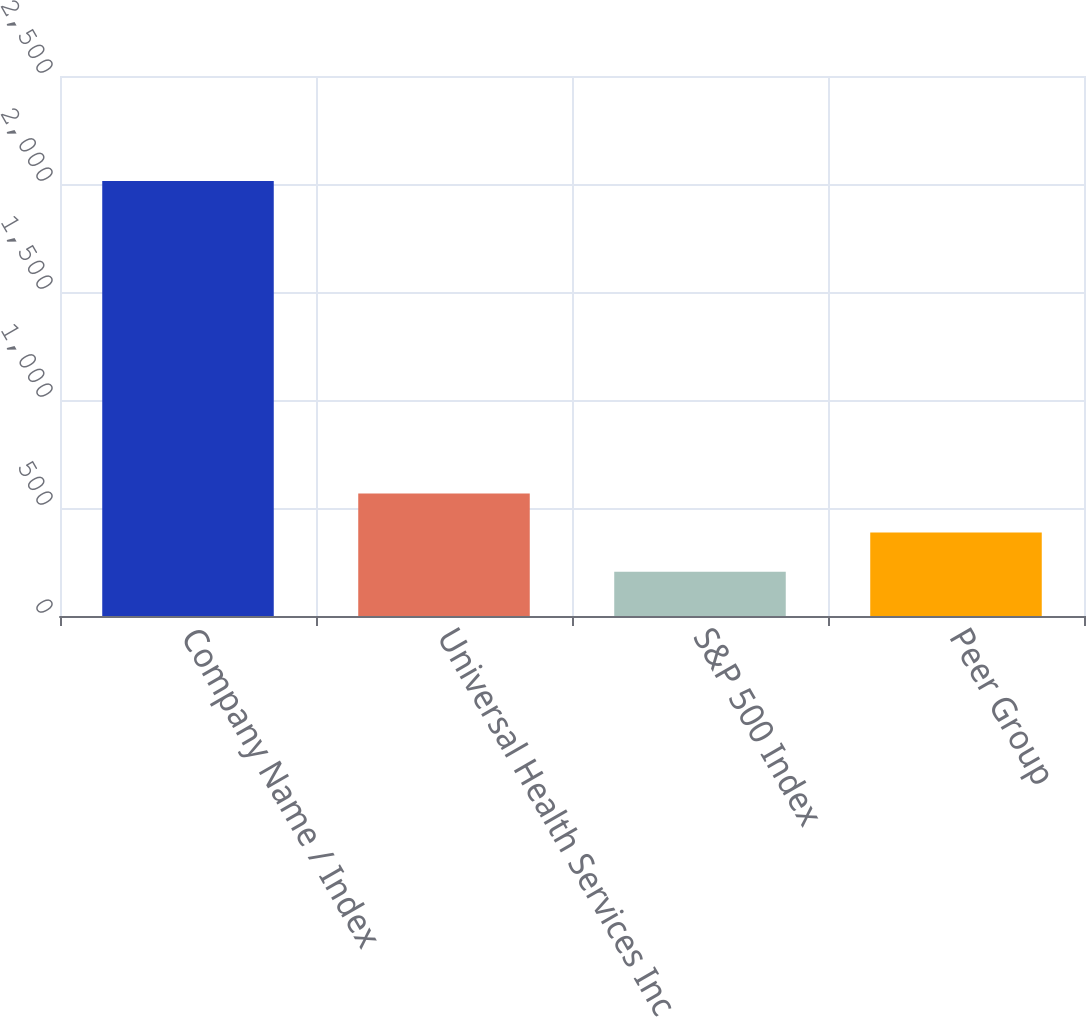Convert chart. <chart><loc_0><loc_0><loc_500><loc_500><bar_chart><fcel>Company Name / Index<fcel>Universal Health Services Inc<fcel>S&P 500 Index<fcel>Peer Group<nl><fcel>2014<fcel>566.92<fcel>205.14<fcel>386.03<nl></chart> 